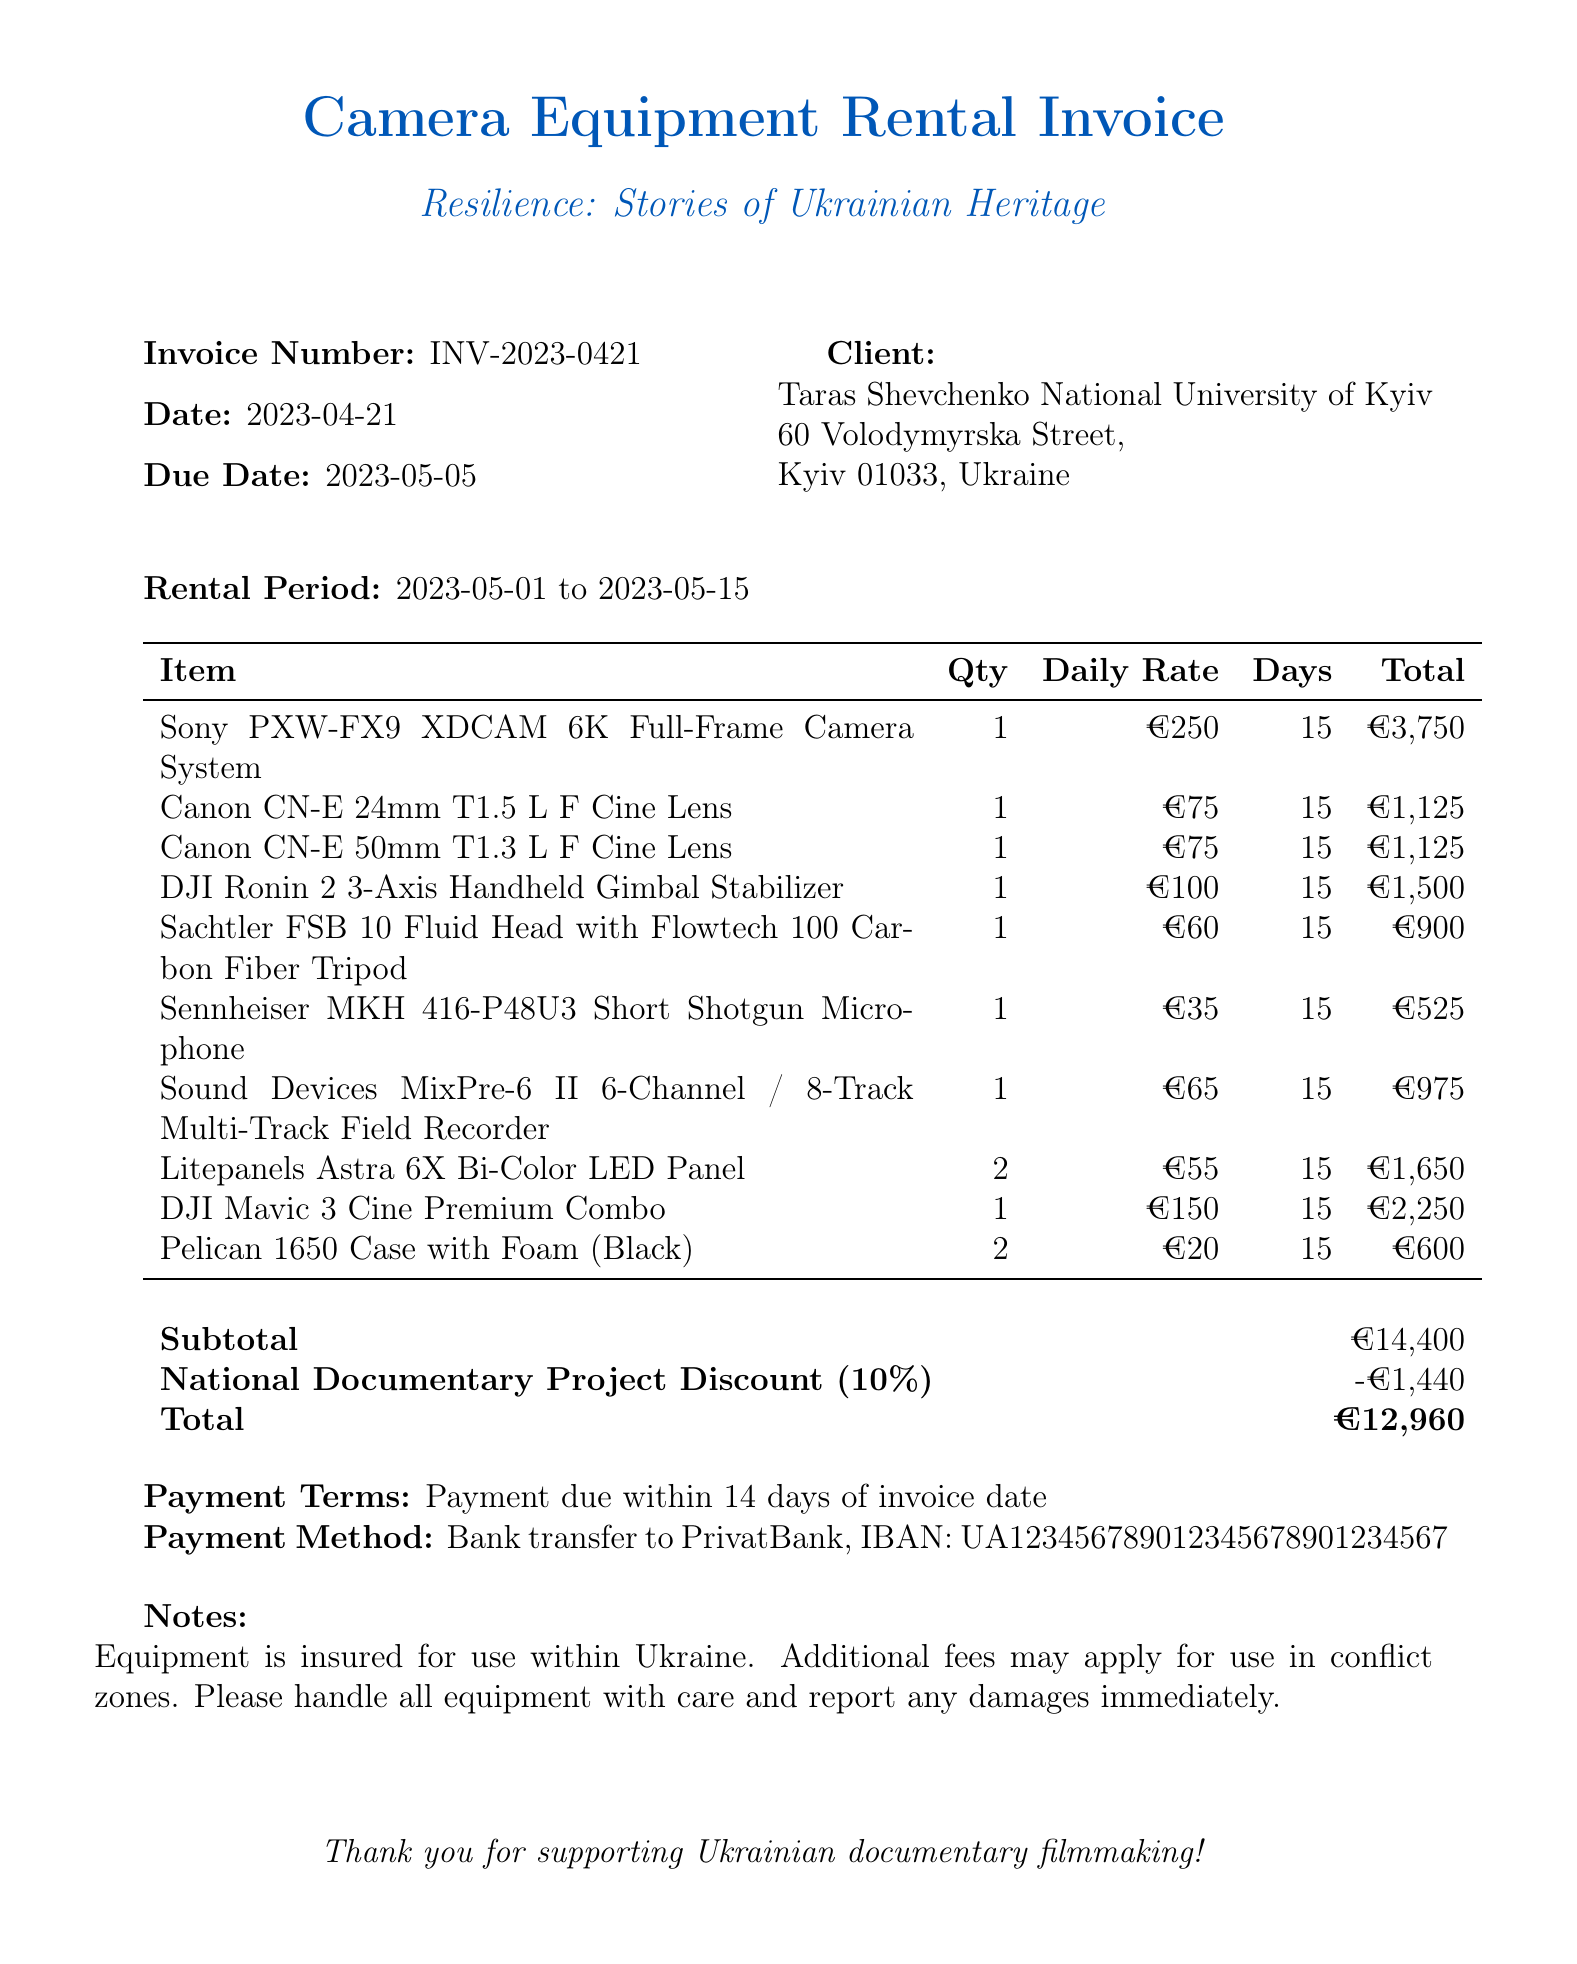What is the invoice number? The invoice number is listed at the top of the document.
Answer: INV-2023-0421 Who is the client? The client's name and address are provided in the document.
Answer: Taras Shevchenko National University of Kyiv What is the rental period? The rental period is specified in the document details.
Answer: 2023-05-01 to 2023-05-15 What is the subtotal amount? The subtotal is clearly stated in the summary of charges.
Answer: €14,400 What discount is applied? The discount section indicates the type and percentage of discount given.
Answer: 10% What is the total amount due? The total due is calculated after applying the discount.
Answer: €12,960 How many days is the camera equipment rented? The number of days is mentioned in the rental period section.
Answer: 15 Which payment method is specified? The payment method is detailed in the payment terms section.
Answer: Bank transfer to PrivatBank What is mentioned regarding equipment insurance? A note about equipment insurance is included in the document.
Answer: Equipment is insured for use within Ukraine 